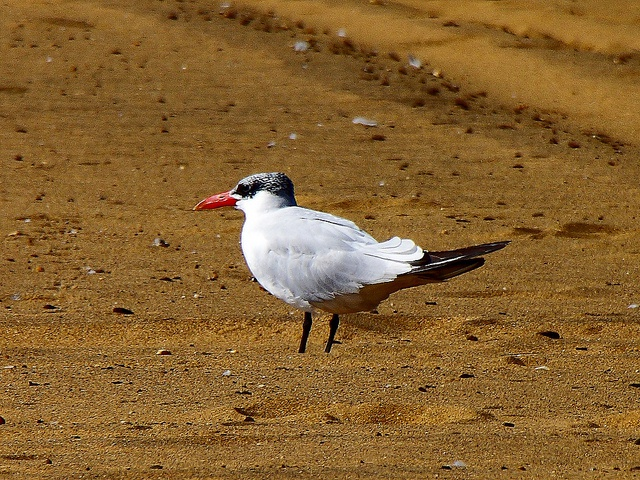Describe the objects in this image and their specific colors. I can see a bird in olive, lightgray, black, darkgray, and maroon tones in this image. 